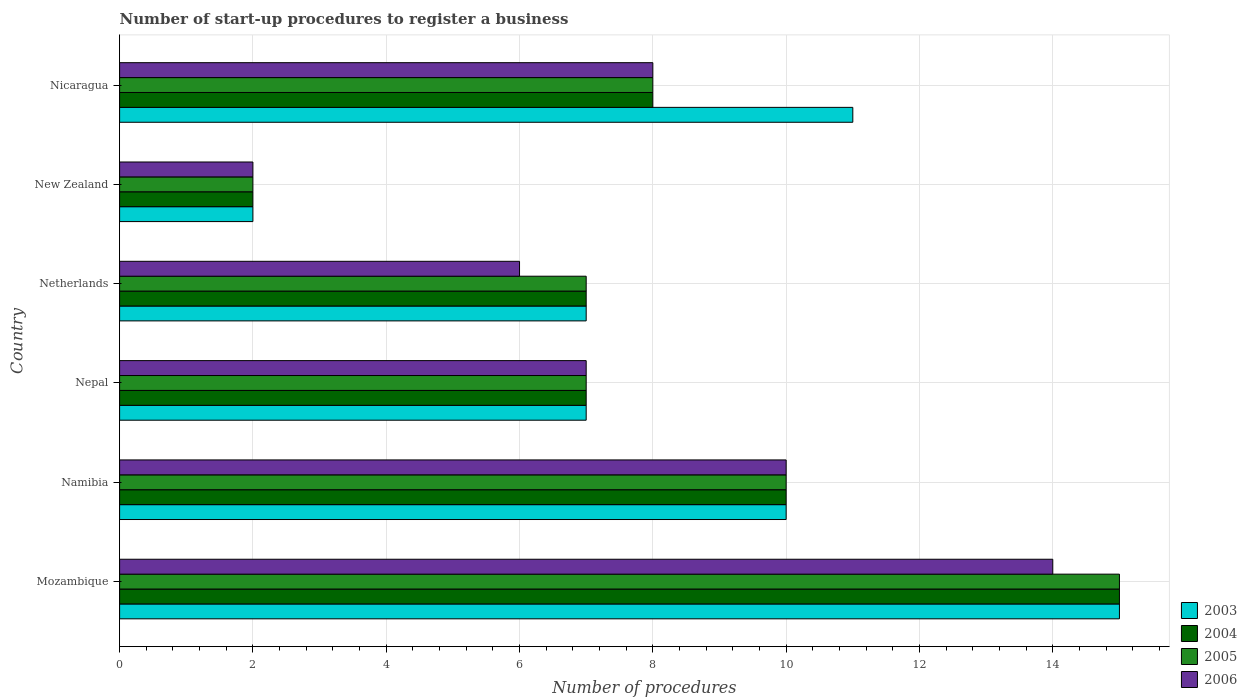How many different coloured bars are there?
Keep it short and to the point. 4. How many groups of bars are there?
Give a very brief answer. 6. Are the number of bars per tick equal to the number of legend labels?
Make the answer very short. Yes. How many bars are there on the 4th tick from the top?
Your answer should be very brief. 4. How many bars are there on the 3rd tick from the bottom?
Your answer should be very brief. 4. In how many cases, is the number of bars for a given country not equal to the number of legend labels?
Your response must be concise. 0. What is the number of procedures required to register a business in 2003 in Netherlands?
Your answer should be very brief. 7. In which country was the number of procedures required to register a business in 2004 maximum?
Provide a succinct answer. Mozambique. In which country was the number of procedures required to register a business in 2004 minimum?
Ensure brevity in your answer.  New Zealand. What is the total number of procedures required to register a business in 2004 in the graph?
Offer a terse response. 49. What is the difference between the number of procedures required to register a business in 2006 in Namibia and that in New Zealand?
Provide a succinct answer. 8. What is the difference between the number of procedures required to register a business in 2006 in Mozambique and the number of procedures required to register a business in 2005 in Nicaragua?
Provide a succinct answer. 6. What is the average number of procedures required to register a business in 2006 per country?
Your answer should be compact. 7.83. What is the ratio of the number of procedures required to register a business in 2005 in Nepal to that in Nicaragua?
Offer a very short reply. 0.88. What is the difference between the highest and the second highest number of procedures required to register a business in 2005?
Make the answer very short. 5. What is the difference between the highest and the lowest number of procedures required to register a business in 2006?
Ensure brevity in your answer.  12. What does the 2nd bar from the top in Nicaragua represents?
Keep it short and to the point. 2005. Is it the case that in every country, the sum of the number of procedures required to register a business in 2006 and number of procedures required to register a business in 2005 is greater than the number of procedures required to register a business in 2003?
Provide a short and direct response. Yes. Are all the bars in the graph horizontal?
Keep it short and to the point. Yes. How many countries are there in the graph?
Your answer should be compact. 6. Are the values on the major ticks of X-axis written in scientific E-notation?
Give a very brief answer. No. Does the graph contain any zero values?
Make the answer very short. No. How many legend labels are there?
Offer a very short reply. 4. How are the legend labels stacked?
Provide a succinct answer. Vertical. What is the title of the graph?
Provide a succinct answer. Number of start-up procedures to register a business. What is the label or title of the X-axis?
Provide a succinct answer. Number of procedures. What is the label or title of the Y-axis?
Make the answer very short. Country. What is the Number of procedures in 2004 in Mozambique?
Your answer should be compact. 15. What is the Number of procedures of 2005 in Mozambique?
Offer a very short reply. 15. What is the Number of procedures in 2003 in Namibia?
Keep it short and to the point. 10. What is the Number of procedures of 2004 in Namibia?
Keep it short and to the point. 10. What is the Number of procedures in 2004 in Netherlands?
Provide a short and direct response. 7. What is the Number of procedures of 2004 in New Zealand?
Give a very brief answer. 2. What is the Number of procedures in 2006 in New Zealand?
Your answer should be very brief. 2. What is the Number of procedures in 2005 in Nicaragua?
Offer a terse response. 8. Across all countries, what is the maximum Number of procedures in 2003?
Ensure brevity in your answer.  15. Across all countries, what is the maximum Number of procedures of 2004?
Your response must be concise. 15. Across all countries, what is the maximum Number of procedures in 2006?
Provide a short and direct response. 14. Across all countries, what is the minimum Number of procedures in 2003?
Provide a short and direct response. 2. Across all countries, what is the minimum Number of procedures in 2004?
Your answer should be compact. 2. Across all countries, what is the minimum Number of procedures in 2005?
Make the answer very short. 2. Across all countries, what is the minimum Number of procedures of 2006?
Your answer should be compact. 2. What is the total Number of procedures of 2006 in the graph?
Keep it short and to the point. 47. What is the difference between the Number of procedures in 2004 in Mozambique and that in Namibia?
Your answer should be compact. 5. What is the difference between the Number of procedures of 2006 in Mozambique and that in Namibia?
Offer a very short reply. 4. What is the difference between the Number of procedures of 2005 in Mozambique and that in Nepal?
Ensure brevity in your answer.  8. What is the difference between the Number of procedures in 2006 in Mozambique and that in Nepal?
Offer a terse response. 7. What is the difference between the Number of procedures in 2005 in Mozambique and that in Netherlands?
Ensure brevity in your answer.  8. What is the difference between the Number of procedures in 2006 in Mozambique and that in Netherlands?
Offer a very short reply. 8. What is the difference between the Number of procedures of 2004 in Mozambique and that in New Zealand?
Your response must be concise. 13. What is the difference between the Number of procedures of 2005 in Mozambique and that in New Zealand?
Offer a terse response. 13. What is the difference between the Number of procedures of 2004 in Mozambique and that in Nicaragua?
Offer a terse response. 7. What is the difference between the Number of procedures of 2006 in Mozambique and that in Nicaragua?
Offer a terse response. 6. What is the difference between the Number of procedures of 2004 in Namibia and that in Netherlands?
Your answer should be compact. 3. What is the difference between the Number of procedures of 2005 in Namibia and that in Netherlands?
Provide a succinct answer. 3. What is the difference between the Number of procedures of 2006 in Namibia and that in Netherlands?
Offer a terse response. 4. What is the difference between the Number of procedures in 2003 in Namibia and that in New Zealand?
Give a very brief answer. 8. What is the difference between the Number of procedures in 2004 in Namibia and that in New Zealand?
Offer a very short reply. 8. What is the difference between the Number of procedures in 2006 in Namibia and that in New Zealand?
Make the answer very short. 8. What is the difference between the Number of procedures in 2004 in Namibia and that in Nicaragua?
Your answer should be very brief. 2. What is the difference between the Number of procedures in 2005 in Namibia and that in Nicaragua?
Your response must be concise. 2. What is the difference between the Number of procedures of 2005 in Nepal and that in Netherlands?
Provide a succinct answer. 0. What is the difference between the Number of procedures in 2006 in Nepal and that in Netherlands?
Make the answer very short. 1. What is the difference between the Number of procedures of 2003 in Nepal and that in New Zealand?
Offer a terse response. 5. What is the difference between the Number of procedures of 2004 in Nepal and that in New Zealand?
Ensure brevity in your answer.  5. What is the difference between the Number of procedures of 2006 in Nepal and that in New Zealand?
Give a very brief answer. 5. What is the difference between the Number of procedures in 2004 in Nepal and that in Nicaragua?
Offer a very short reply. -1. What is the difference between the Number of procedures in 2003 in Netherlands and that in New Zealand?
Offer a very short reply. 5. What is the difference between the Number of procedures in 2004 in Netherlands and that in New Zealand?
Your answer should be very brief. 5. What is the difference between the Number of procedures of 2004 in Netherlands and that in Nicaragua?
Give a very brief answer. -1. What is the difference between the Number of procedures of 2003 in New Zealand and that in Nicaragua?
Ensure brevity in your answer.  -9. What is the difference between the Number of procedures in 2004 in New Zealand and that in Nicaragua?
Make the answer very short. -6. What is the difference between the Number of procedures in 2006 in New Zealand and that in Nicaragua?
Give a very brief answer. -6. What is the difference between the Number of procedures of 2003 in Mozambique and the Number of procedures of 2004 in Namibia?
Provide a succinct answer. 5. What is the difference between the Number of procedures of 2004 in Mozambique and the Number of procedures of 2006 in Namibia?
Keep it short and to the point. 5. What is the difference between the Number of procedures of 2003 in Mozambique and the Number of procedures of 2004 in Nepal?
Your answer should be compact. 8. What is the difference between the Number of procedures of 2003 in Mozambique and the Number of procedures of 2006 in Nepal?
Your response must be concise. 8. What is the difference between the Number of procedures in 2004 in Mozambique and the Number of procedures in 2005 in Nepal?
Provide a succinct answer. 8. What is the difference between the Number of procedures in 2004 in Mozambique and the Number of procedures in 2006 in Nepal?
Your answer should be very brief. 8. What is the difference between the Number of procedures in 2005 in Mozambique and the Number of procedures in 2006 in Nepal?
Ensure brevity in your answer.  8. What is the difference between the Number of procedures in 2003 in Mozambique and the Number of procedures in 2004 in Netherlands?
Ensure brevity in your answer.  8. What is the difference between the Number of procedures in 2003 in Mozambique and the Number of procedures in 2005 in Netherlands?
Provide a succinct answer. 8. What is the difference between the Number of procedures of 2004 in Mozambique and the Number of procedures of 2005 in Netherlands?
Offer a terse response. 8. What is the difference between the Number of procedures of 2004 in Mozambique and the Number of procedures of 2006 in Netherlands?
Provide a short and direct response. 9. What is the difference between the Number of procedures of 2005 in Mozambique and the Number of procedures of 2006 in Netherlands?
Keep it short and to the point. 9. What is the difference between the Number of procedures of 2003 in Mozambique and the Number of procedures of 2004 in New Zealand?
Give a very brief answer. 13. What is the difference between the Number of procedures in 2003 in Mozambique and the Number of procedures in 2006 in New Zealand?
Provide a succinct answer. 13. What is the difference between the Number of procedures of 2003 in Mozambique and the Number of procedures of 2004 in Nicaragua?
Your answer should be compact. 7. What is the difference between the Number of procedures in 2003 in Mozambique and the Number of procedures in 2005 in Nicaragua?
Offer a terse response. 7. What is the difference between the Number of procedures in 2003 in Mozambique and the Number of procedures in 2006 in Nicaragua?
Provide a succinct answer. 7. What is the difference between the Number of procedures of 2004 in Mozambique and the Number of procedures of 2005 in Nicaragua?
Ensure brevity in your answer.  7. What is the difference between the Number of procedures in 2004 in Mozambique and the Number of procedures in 2006 in Nicaragua?
Provide a short and direct response. 7. What is the difference between the Number of procedures in 2005 in Mozambique and the Number of procedures in 2006 in Nicaragua?
Provide a succinct answer. 7. What is the difference between the Number of procedures of 2003 in Namibia and the Number of procedures of 2004 in Nepal?
Offer a very short reply. 3. What is the difference between the Number of procedures in 2003 in Namibia and the Number of procedures in 2004 in Netherlands?
Your answer should be compact. 3. What is the difference between the Number of procedures of 2003 in Namibia and the Number of procedures of 2005 in Netherlands?
Your answer should be compact. 3. What is the difference between the Number of procedures in 2004 in Namibia and the Number of procedures in 2005 in Netherlands?
Give a very brief answer. 3. What is the difference between the Number of procedures in 2004 in Namibia and the Number of procedures in 2006 in Netherlands?
Make the answer very short. 4. What is the difference between the Number of procedures in 2005 in Namibia and the Number of procedures in 2006 in Netherlands?
Provide a short and direct response. 4. What is the difference between the Number of procedures of 2003 in Namibia and the Number of procedures of 2004 in New Zealand?
Make the answer very short. 8. What is the difference between the Number of procedures in 2004 in Namibia and the Number of procedures in 2006 in New Zealand?
Keep it short and to the point. 8. What is the difference between the Number of procedures in 2005 in Namibia and the Number of procedures in 2006 in New Zealand?
Ensure brevity in your answer.  8. What is the difference between the Number of procedures in 2003 in Namibia and the Number of procedures in 2004 in Nicaragua?
Offer a very short reply. 2. What is the difference between the Number of procedures of 2003 in Namibia and the Number of procedures of 2005 in Nicaragua?
Give a very brief answer. 2. What is the difference between the Number of procedures in 2004 in Namibia and the Number of procedures in 2005 in Nicaragua?
Your answer should be compact. 2. What is the difference between the Number of procedures in 2003 in Nepal and the Number of procedures in 2006 in Netherlands?
Keep it short and to the point. 1. What is the difference between the Number of procedures of 2004 in Nepal and the Number of procedures of 2005 in Netherlands?
Make the answer very short. 0. What is the difference between the Number of procedures in 2004 in Nepal and the Number of procedures in 2006 in Netherlands?
Ensure brevity in your answer.  1. What is the difference between the Number of procedures of 2003 in Nepal and the Number of procedures of 2006 in New Zealand?
Offer a terse response. 5. What is the difference between the Number of procedures in 2004 in Nepal and the Number of procedures in 2006 in New Zealand?
Give a very brief answer. 5. What is the difference between the Number of procedures of 2005 in Nepal and the Number of procedures of 2006 in New Zealand?
Ensure brevity in your answer.  5. What is the difference between the Number of procedures in 2003 in Nepal and the Number of procedures in 2005 in Nicaragua?
Give a very brief answer. -1. What is the difference between the Number of procedures of 2004 in Nepal and the Number of procedures of 2005 in Nicaragua?
Provide a succinct answer. -1. What is the difference between the Number of procedures in 2005 in Nepal and the Number of procedures in 2006 in Nicaragua?
Give a very brief answer. -1. What is the difference between the Number of procedures in 2003 in Netherlands and the Number of procedures in 2006 in New Zealand?
Your answer should be very brief. 5. What is the difference between the Number of procedures of 2004 in Netherlands and the Number of procedures of 2005 in New Zealand?
Keep it short and to the point. 5. What is the difference between the Number of procedures in 2003 in Netherlands and the Number of procedures in 2004 in Nicaragua?
Your answer should be compact. -1. What is the difference between the Number of procedures of 2004 in Netherlands and the Number of procedures of 2005 in Nicaragua?
Offer a very short reply. -1. What is the difference between the Number of procedures in 2004 in Netherlands and the Number of procedures in 2006 in Nicaragua?
Provide a succinct answer. -1. What is the difference between the Number of procedures in 2005 in Netherlands and the Number of procedures in 2006 in Nicaragua?
Your response must be concise. -1. What is the average Number of procedures of 2003 per country?
Provide a short and direct response. 8.67. What is the average Number of procedures in 2004 per country?
Your answer should be compact. 8.17. What is the average Number of procedures in 2005 per country?
Your answer should be compact. 8.17. What is the average Number of procedures in 2006 per country?
Give a very brief answer. 7.83. What is the difference between the Number of procedures in 2003 and Number of procedures in 2004 in Mozambique?
Offer a very short reply. 0. What is the difference between the Number of procedures of 2003 and Number of procedures of 2005 in Mozambique?
Ensure brevity in your answer.  0. What is the difference between the Number of procedures in 2004 and Number of procedures in 2005 in Mozambique?
Provide a succinct answer. 0. What is the difference between the Number of procedures of 2004 and Number of procedures of 2006 in Mozambique?
Make the answer very short. 1. What is the difference between the Number of procedures in 2003 and Number of procedures in 2006 in Namibia?
Your response must be concise. 0. What is the difference between the Number of procedures in 2004 and Number of procedures in 2005 in Namibia?
Provide a short and direct response. 0. What is the difference between the Number of procedures in 2004 and Number of procedures in 2006 in Namibia?
Provide a short and direct response. 0. What is the difference between the Number of procedures of 2005 and Number of procedures of 2006 in Namibia?
Make the answer very short. 0. What is the difference between the Number of procedures of 2003 and Number of procedures of 2004 in Nepal?
Your answer should be very brief. 0. What is the difference between the Number of procedures in 2003 and Number of procedures in 2005 in Nepal?
Offer a terse response. 0. What is the difference between the Number of procedures of 2003 and Number of procedures of 2006 in Nepal?
Ensure brevity in your answer.  0. What is the difference between the Number of procedures of 2004 and Number of procedures of 2005 in Nepal?
Provide a succinct answer. 0. What is the difference between the Number of procedures of 2005 and Number of procedures of 2006 in Nepal?
Ensure brevity in your answer.  0. What is the difference between the Number of procedures of 2003 and Number of procedures of 2004 in Netherlands?
Keep it short and to the point. 0. What is the difference between the Number of procedures in 2003 and Number of procedures in 2005 in Netherlands?
Give a very brief answer. 0. What is the difference between the Number of procedures in 2003 and Number of procedures in 2006 in Netherlands?
Your response must be concise. 1. What is the difference between the Number of procedures of 2004 and Number of procedures of 2006 in Netherlands?
Provide a short and direct response. 1. What is the difference between the Number of procedures in 2003 and Number of procedures in 2006 in New Zealand?
Give a very brief answer. 0. What is the difference between the Number of procedures of 2004 and Number of procedures of 2005 in New Zealand?
Provide a short and direct response. 0. What is the difference between the Number of procedures in 2005 and Number of procedures in 2006 in New Zealand?
Make the answer very short. 0. What is the difference between the Number of procedures in 2003 and Number of procedures in 2006 in Nicaragua?
Keep it short and to the point. 3. What is the difference between the Number of procedures of 2004 and Number of procedures of 2005 in Nicaragua?
Keep it short and to the point. 0. What is the difference between the Number of procedures of 2004 and Number of procedures of 2006 in Nicaragua?
Offer a terse response. 0. What is the difference between the Number of procedures in 2005 and Number of procedures in 2006 in Nicaragua?
Ensure brevity in your answer.  0. What is the ratio of the Number of procedures in 2003 in Mozambique to that in Namibia?
Keep it short and to the point. 1.5. What is the ratio of the Number of procedures in 2004 in Mozambique to that in Namibia?
Offer a very short reply. 1.5. What is the ratio of the Number of procedures of 2005 in Mozambique to that in Namibia?
Provide a succinct answer. 1.5. What is the ratio of the Number of procedures in 2006 in Mozambique to that in Namibia?
Keep it short and to the point. 1.4. What is the ratio of the Number of procedures of 2003 in Mozambique to that in Nepal?
Your answer should be compact. 2.14. What is the ratio of the Number of procedures in 2004 in Mozambique to that in Nepal?
Offer a terse response. 2.14. What is the ratio of the Number of procedures of 2005 in Mozambique to that in Nepal?
Give a very brief answer. 2.14. What is the ratio of the Number of procedures in 2003 in Mozambique to that in Netherlands?
Your response must be concise. 2.14. What is the ratio of the Number of procedures of 2004 in Mozambique to that in Netherlands?
Give a very brief answer. 2.14. What is the ratio of the Number of procedures of 2005 in Mozambique to that in Netherlands?
Give a very brief answer. 2.14. What is the ratio of the Number of procedures in 2006 in Mozambique to that in Netherlands?
Make the answer very short. 2.33. What is the ratio of the Number of procedures in 2006 in Mozambique to that in New Zealand?
Your response must be concise. 7. What is the ratio of the Number of procedures in 2003 in Mozambique to that in Nicaragua?
Ensure brevity in your answer.  1.36. What is the ratio of the Number of procedures in 2004 in Mozambique to that in Nicaragua?
Make the answer very short. 1.88. What is the ratio of the Number of procedures of 2005 in Mozambique to that in Nicaragua?
Your answer should be very brief. 1.88. What is the ratio of the Number of procedures of 2006 in Mozambique to that in Nicaragua?
Offer a very short reply. 1.75. What is the ratio of the Number of procedures in 2003 in Namibia to that in Nepal?
Keep it short and to the point. 1.43. What is the ratio of the Number of procedures of 2004 in Namibia to that in Nepal?
Provide a succinct answer. 1.43. What is the ratio of the Number of procedures in 2005 in Namibia to that in Nepal?
Your answer should be compact. 1.43. What is the ratio of the Number of procedures in 2006 in Namibia to that in Nepal?
Your answer should be very brief. 1.43. What is the ratio of the Number of procedures of 2003 in Namibia to that in Netherlands?
Offer a terse response. 1.43. What is the ratio of the Number of procedures of 2004 in Namibia to that in Netherlands?
Your response must be concise. 1.43. What is the ratio of the Number of procedures of 2005 in Namibia to that in Netherlands?
Provide a short and direct response. 1.43. What is the ratio of the Number of procedures in 2006 in Namibia to that in Netherlands?
Give a very brief answer. 1.67. What is the ratio of the Number of procedures in 2006 in Namibia to that in New Zealand?
Make the answer very short. 5. What is the ratio of the Number of procedures of 2005 in Namibia to that in Nicaragua?
Offer a terse response. 1.25. What is the ratio of the Number of procedures in 2006 in Namibia to that in Nicaragua?
Your answer should be compact. 1.25. What is the ratio of the Number of procedures of 2004 in Nepal to that in Netherlands?
Your answer should be compact. 1. What is the ratio of the Number of procedures of 2005 in Nepal to that in Netherlands?
Make the answer very short. 1. What is the ratio of the Number of procedures of 2004 in Nepal to that in New Zealand?
Offer a terse response. 3.5. What is the ratio of the Number of procedures in 2005 in Nepal to that in New Zealand?
Your answer should be very brief. 3.5. What is the ratio of the Number of procedures of 2003 in Nepal to that in Nicaragua?
Provide a succinct answer. 0.64. What is the ratio of the Number of procedures of 2003 in Netherlands to that in New Zealand?
Provide a short and direct response. 3.5. What is the ratio of the Number of procedures in 2004 in Netherlands to that in New Zealand?
Give a very brief answer. 3.5. What is the ratio of the Number of procedures in 2005 in Netherlands to that in New Zealand?
Give a very brief answer. 3.5. What is the ratio of the Number of procedures of 2006 in Netherlands to that in New Zealand?
Your answer should be compact. 3. What is the ratio of the Number of procedures in 2003 in Netherlands to that in Nicaragua?
Make the answer very short. 0.64. What is the ratio of the Number of procedures of 2003 in New Zealand to that in Nicaragua?
Provide a short and direct response. 0.18. What is the ratio of the Number of procedures in 2004 in New Zealand to that in Nicaragua?
Your answer should be very brief. 0.25. What is the ratio of the Number of procedures in 2006 in New Zealand to that in Nicaragua?
Offer a terse response. 0.25. What is the difference between the highest and the second highest Number of procedures in 2004?
Offer a very short reply. 5. What is the difference between the highest and the second highest Number of procedures in 2006?
Make the answer very short. 4. What is the difference between the highest and the lowest Number of procedures of 2004?
Your answer should be compact. 13. What is the difference between the highest and the lowest Number of procedures of 2005?
Keep it short and to the point. 13. What is the difference between the highest and the lowest Number of procedures in 2006?
Provide a succinct answer. 12. 